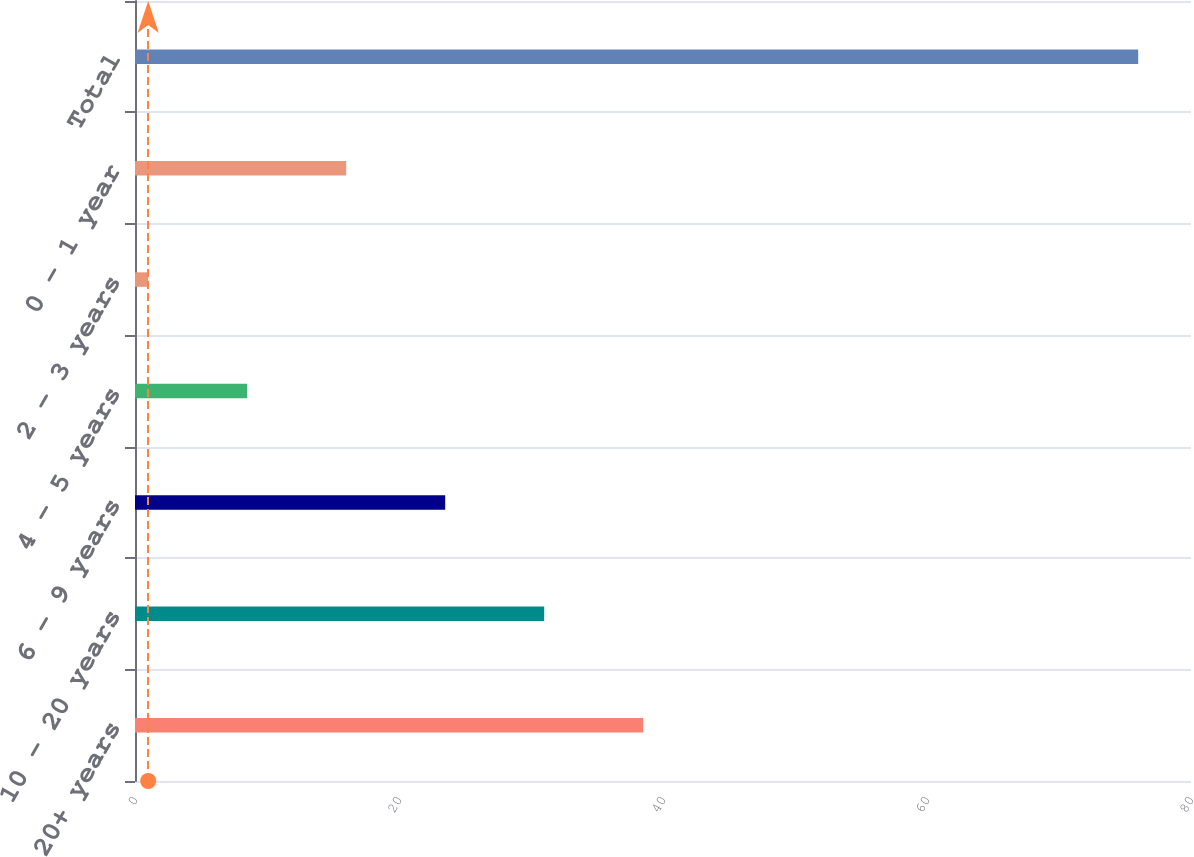<chart> <loc_0><loc_0><loc_500><loc_500><bar_chart><fcel>20+ years<fcel>10 - 20 years<fcel>6 - 9 years<fcel>4 - 5 years<fcel>2 - 3 years<fcel>0 - 1 year<fcel>Total<nl><fcel>38.5<fcel>31<fcel>23.5<fcel>8.5<fcel>1<fcel>16<fcel>76<nl></chart> 